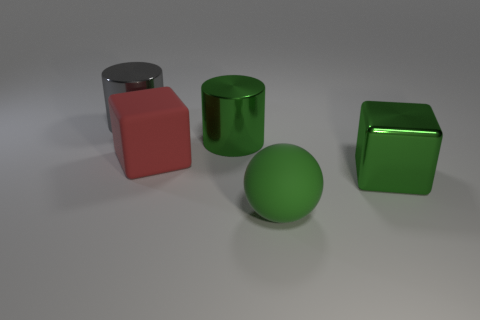Subtract 1 green spheres. How many objects are left? 4 Subtract all cubes. How many objects are left? 3 Subtract 1 cylinders. How many cylinders are left? 1 Subtract all brown cylinders. Subtract all blue blocks. How many cylinders are left? 2 Subtract all brown cylinders. How many cyan cubes are left? 0 Subtract all big blocks. Subtract all matte balls. How many objects are left? 2 Add 3 matte objects. How many matte objects are left? 5 Add 2 green metal cubes. How many green metal cubes exist? 3 Add 2 large blocks. How many objects exist? 7 Subtract all red blocks. How many blocks are left? 1 